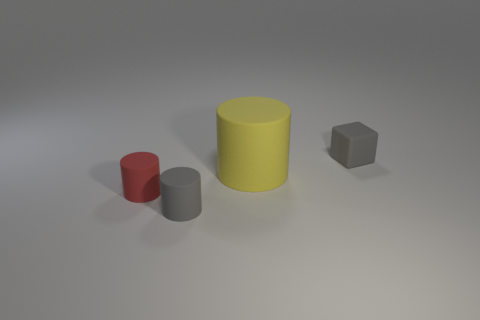Add 2 red rubber cylinders. How many objects exist? 6 Subtract all small red cylinders. How many cylinders are left? 2 Subtract all red cylinders. How many cylinders are left? 2 Subtract all cylinders. How many objects are left? 1 Subtract all blue cylinders. Subtract all purple cubes. How many cylinders are left? 3 Subtract all red cylinders. How many brown cubes are left? 0 Subtract all cylinders. Subtract all brown shiny cylinders. How many objects are left? 1 Add 3 tiny matte cubes. How many tiny matte cubes are left? 4 Add 3 rubber cubes. How many rubber cubes exist? 4 Subtract 0 yellow cubes. How many objects are left? 4 